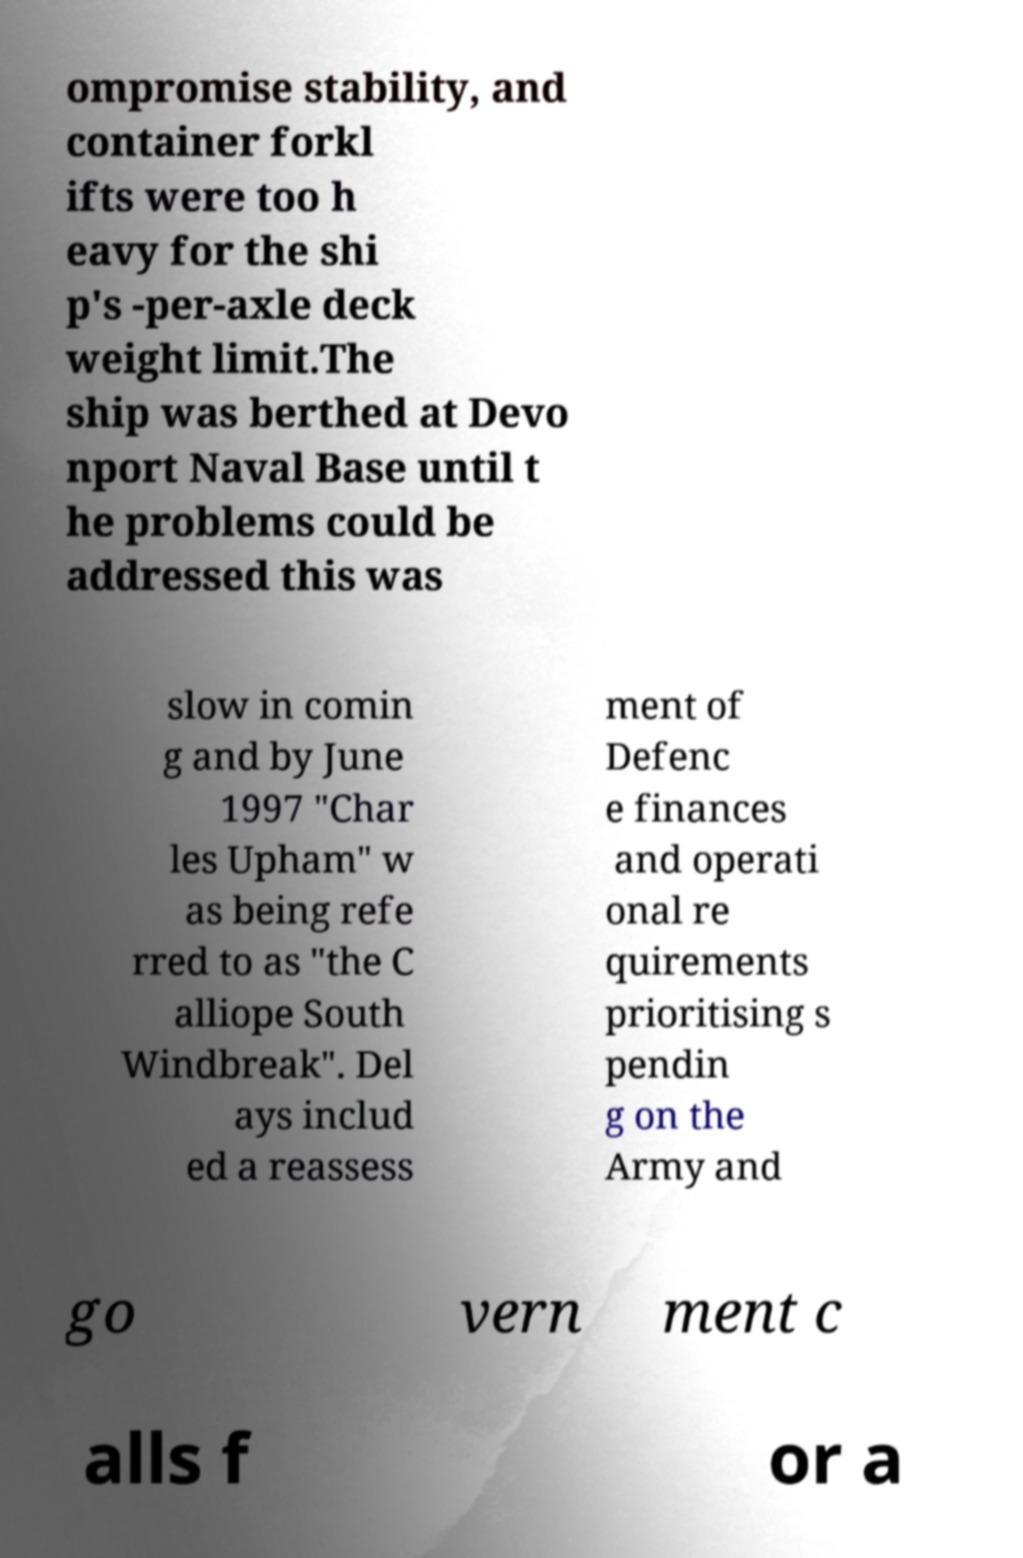There's text embedded in this image that I need extracted. Can you transcribe it verbatim? ompromise stability, and container forkl ifts were too h eavy for the shi p's -per-axle deck weight limit.The ship was berthed at Devo nport Naval Base until t he problems could be addressed this was slow in comin g and by June 1997 "Char les Upham" w as being refe rred to as "the C alliope South Windbreak". Del ays includ ed a reassess ment of Defenc e finances and operati onal re quirements prioritising s pendin g on the Army and go vern ment c alls f or a 